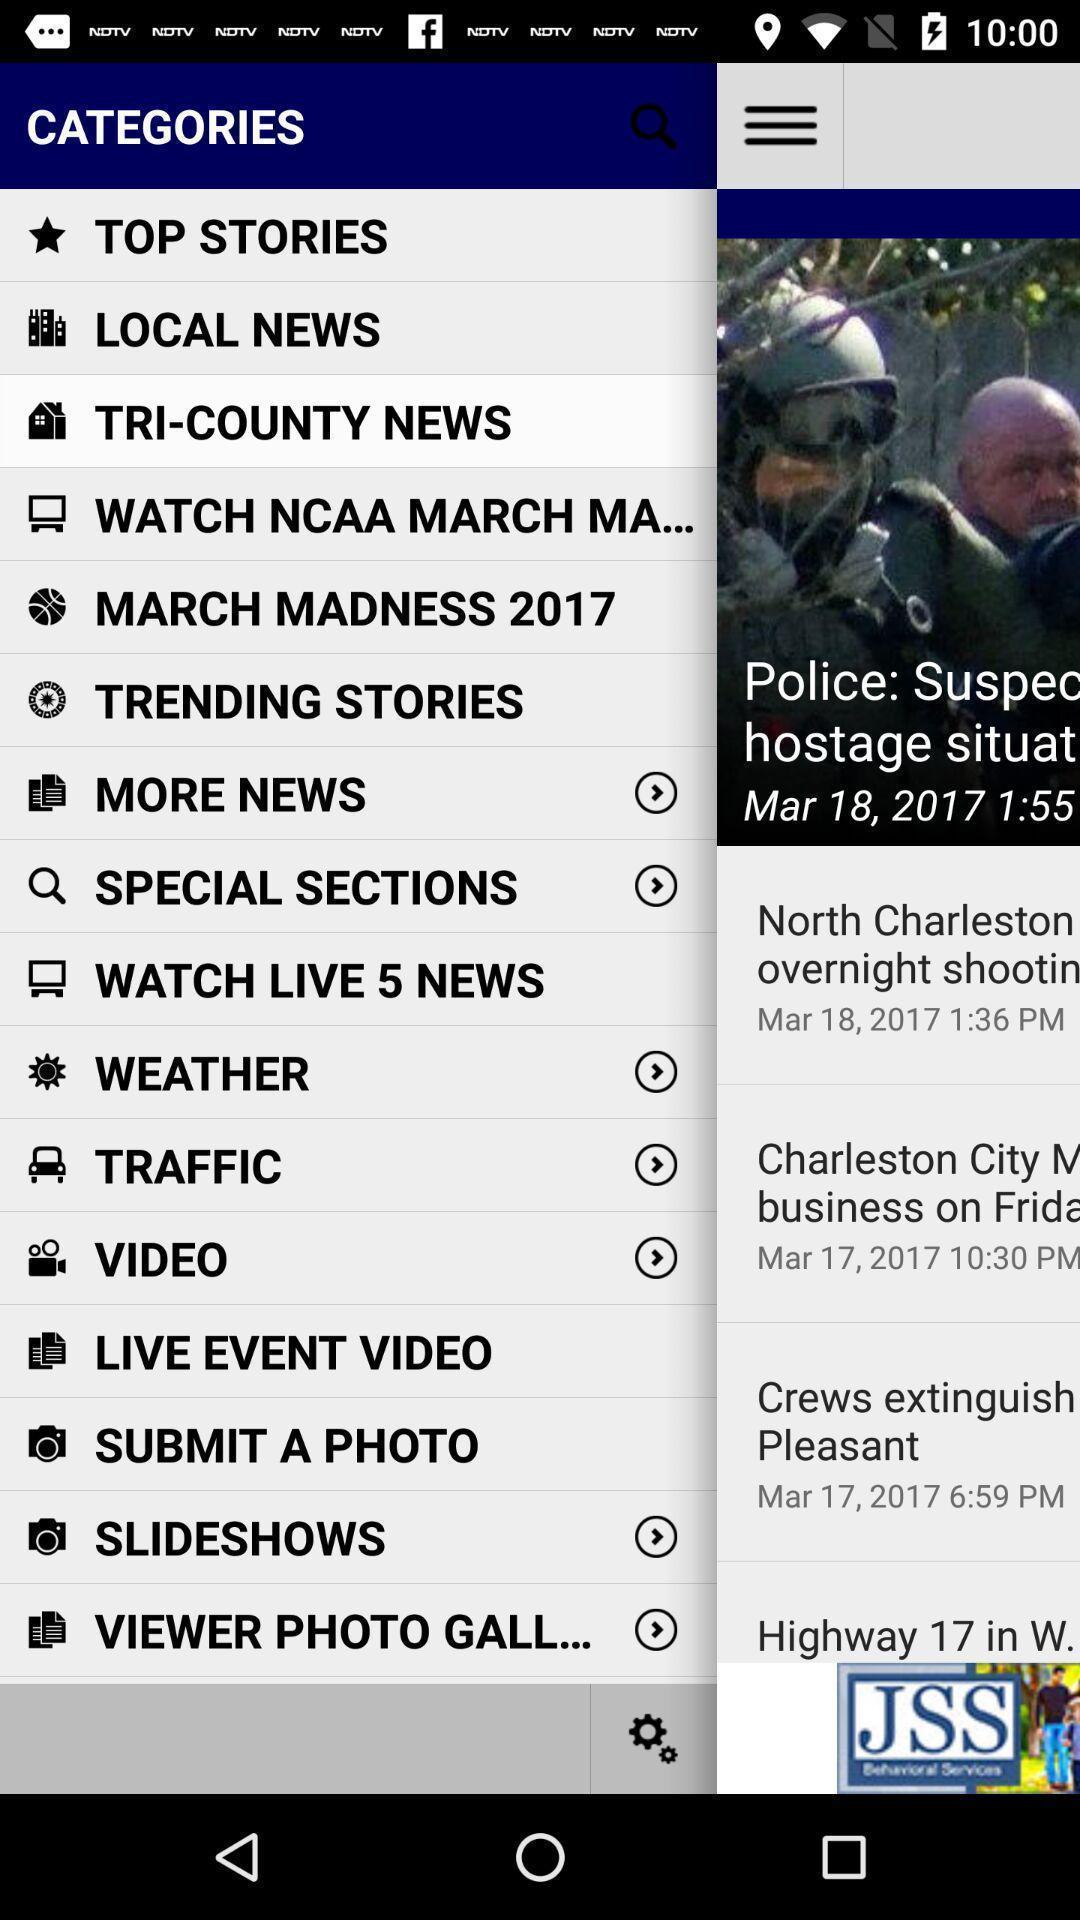Provide a detailed account of this screenshot. Pop-up showing menu in news app. 